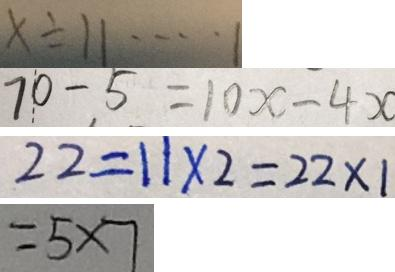Convert formula to latex. <formula><loc_0><loc_0><loc_500><loc_500>x \div 1 1 \cdots 1 
 7 0 - 5 = 1 0 x - 4 x 
 2 2 = 1 1 \times 2 = 2 2 \times 1 
 = 5 \times 7</formula> 